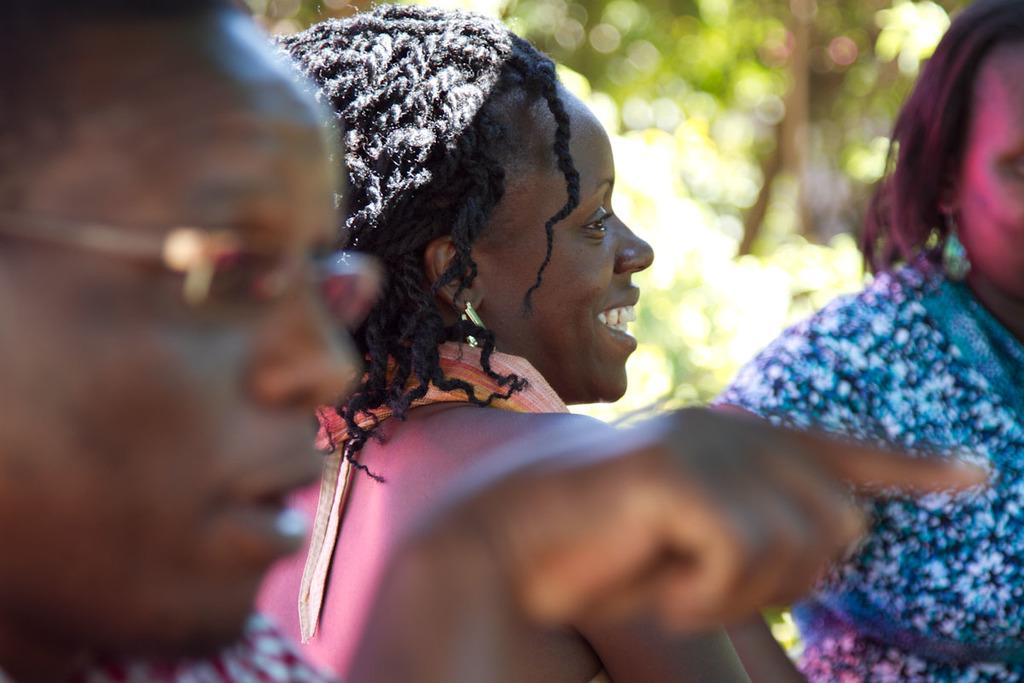How many people are in the image? There are three people in the image: two women and a man. What is the man wearing in the image? The man is wearing glasses in the image. What can be seen in the background of the image? The background of the image includes trees. What type of brick is being used to build the attraction in the image? There is no brick or attraction present in the image; it features two women and a man. What kind of scissors are the women using to cut the trees in the background? There are no scissors or tree-cutting activity depicted in the image. 